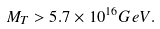<formula> <loc_0><loc_0><loc_500><loc_500>M _ { T } > 5 . 7 \times 1 0 ^ { 1 6 } G e V .</formula> 